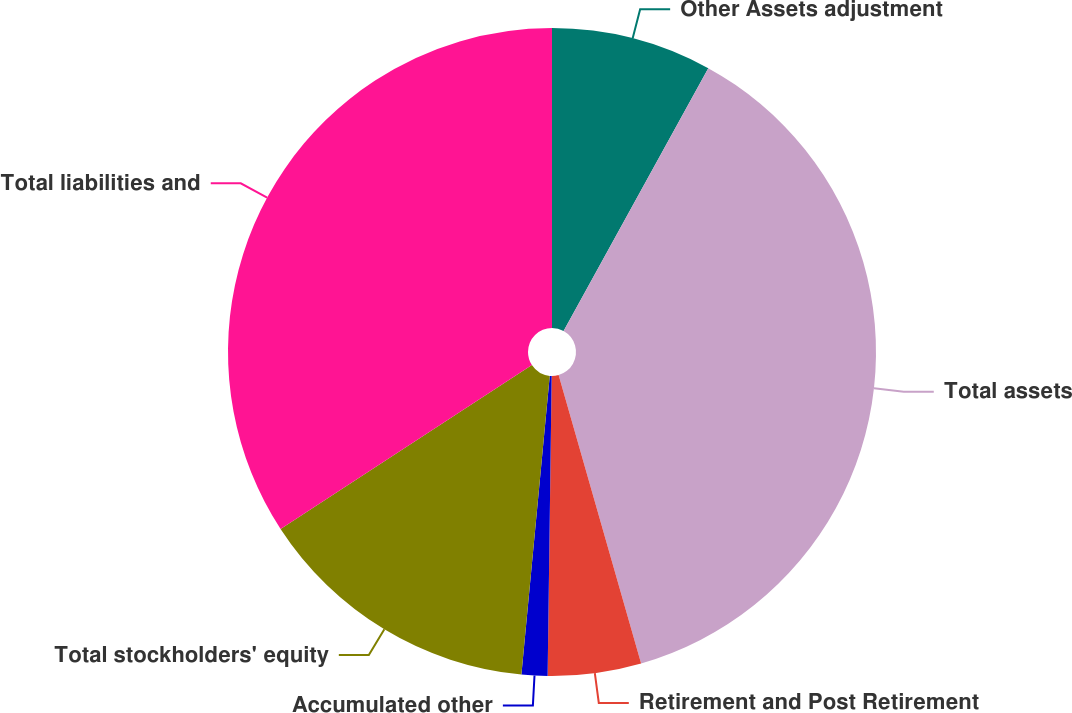Convert chart to OTSL. <chart><loc_0><loc_0><loc_500><loc_500><pie_chart><fcel>Other Assets adjustment<fcel>Total assets<fcel>Retirement and Post Retirement<fcel>Accumulated other<fcel>Total stockholders' equity<fcel>Total liabilities and<nl><fcel>8.01%<fcel>37.55%<fcel>4.65%<fcel>1.29%<fcel>14.3%<fcel>34.19%<nl></chart> 